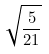Convert formula to latex. <formula><loc_0><loc_0><loc_500><loc_500>\sqrt { \frac { 5 } { 2 1 } }</formula> 